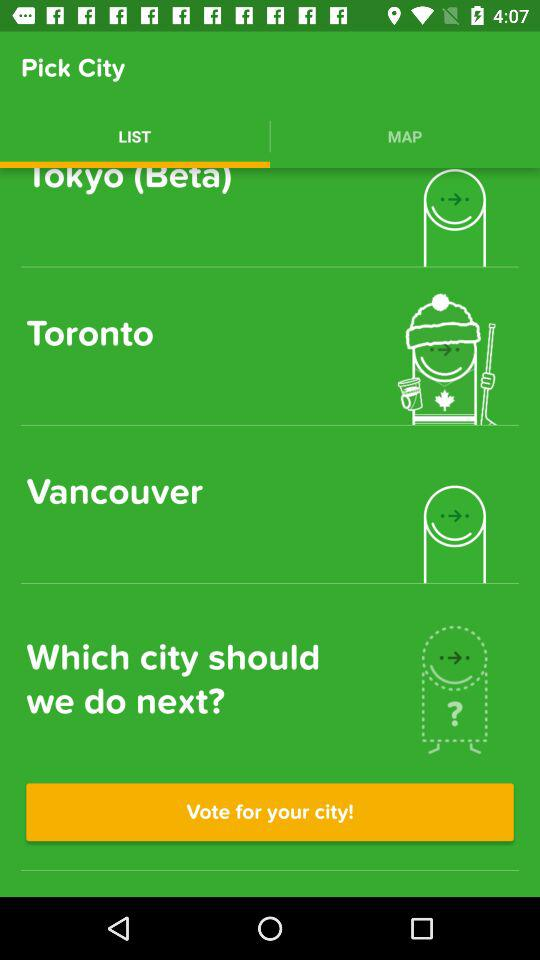How many votes does Vancouver have?
When the provided information is insufficient, respond with <no answer>. <no answer> 